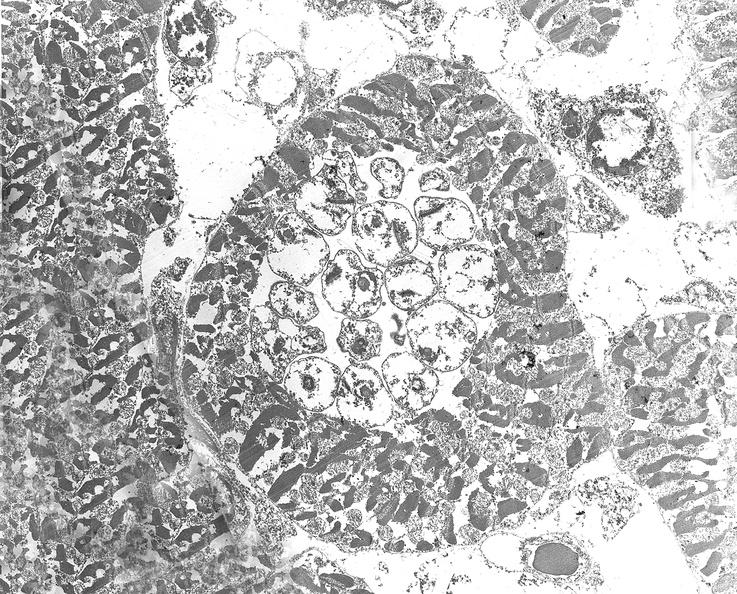s atrophy present?
Answer the question using a single word or phrase. No 